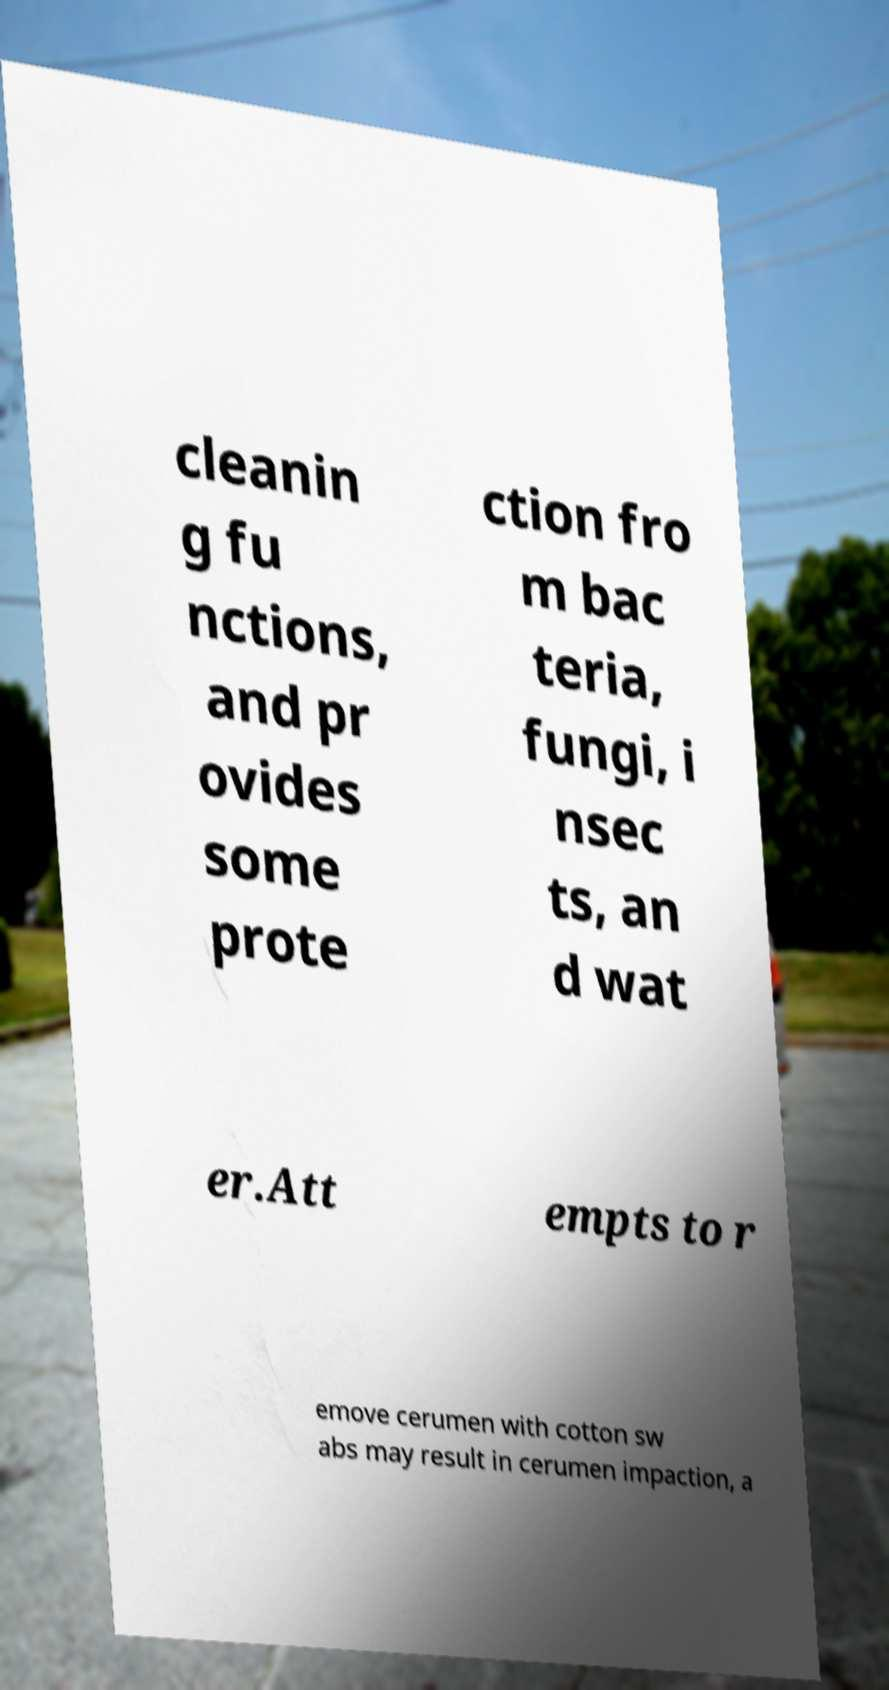Please identify and transcribe the text found in this image. cleanin g fu nctions, and pr ovides some prote ction fro m bac teria, fungi, i nsec ts, an d wat er.Att empts to r emove cerumen with cotton sw abs may result in cerumen impaction, a 